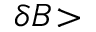Convert formula to latex. <formula><loc_0><loc_0><loc_500><loc_500>\delta B \, ></formula> 